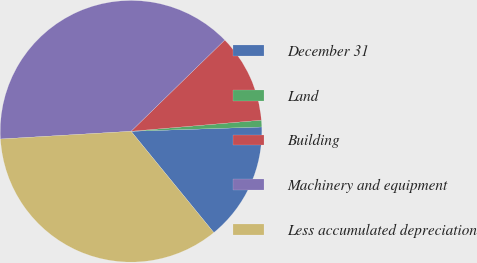<chart> <loc_0><loc_0><loc_500><loc_500><pie_chart><fcel>December 31<fcel>Land<fcel>Building<fcel>Machinery and equipment<fcel>Less accumulated depreciation<nl><fcel>14.62%<fcel>0.83%<fcel>10.93%<fcel>38.65%<fcel>34.96%<nl></chart> 